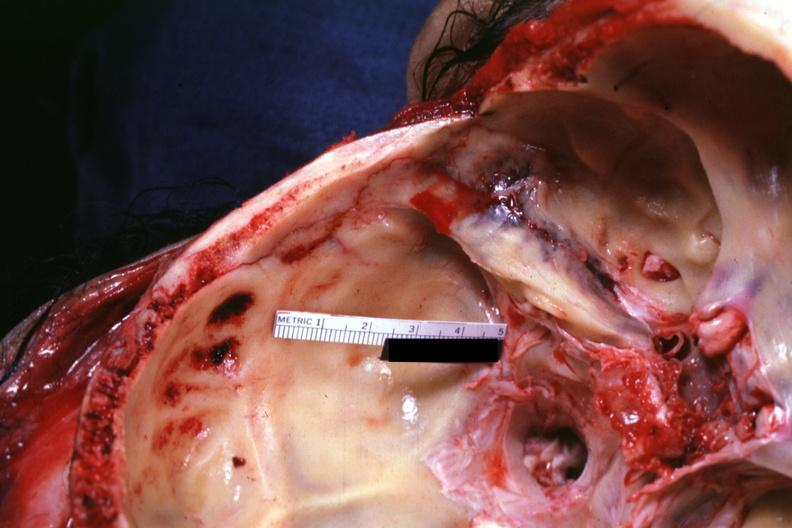what is present?
Answer the question using a single word or phrase. Bone, calvarium 